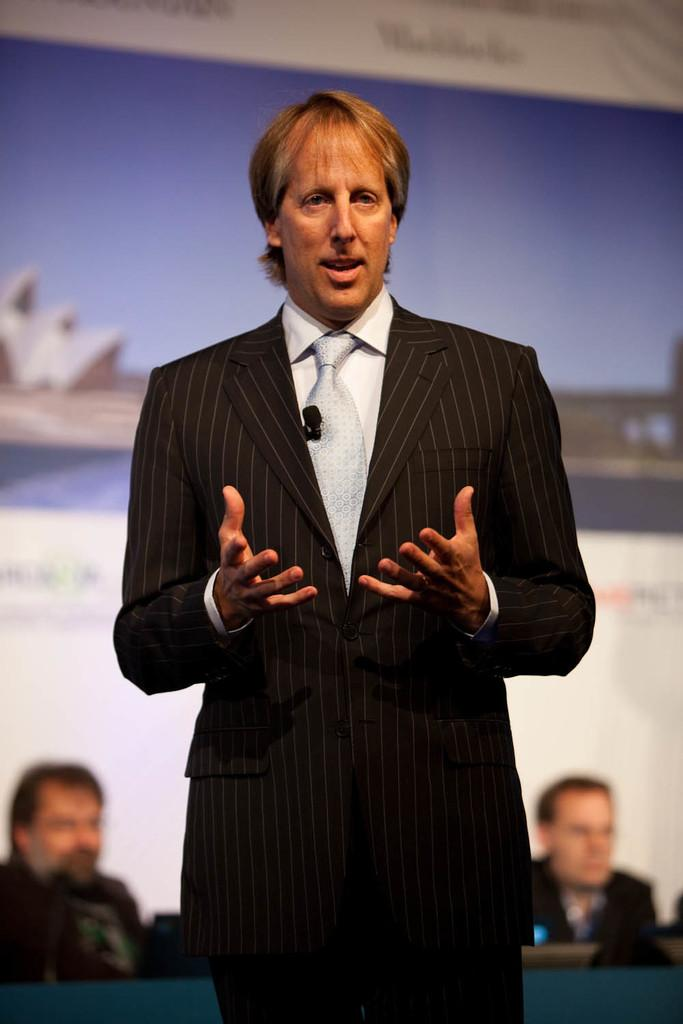What is the primary subject in the image? There is a person standing in the image. Where is the person standing? The person is standing on the floor. What can be seen in the background of the image? There are two men sitting in the background of the image, and there is an advertisement visible as well. What are the two men sitting on? The two men are sitting on chairs. How many boys are part of the committee in the image? There is no committee or boys present in the image. What type of bulb is used to illuminate the advertisement in the image? There is no information about the type of bulb used to illuminate the advertisement in the image. 